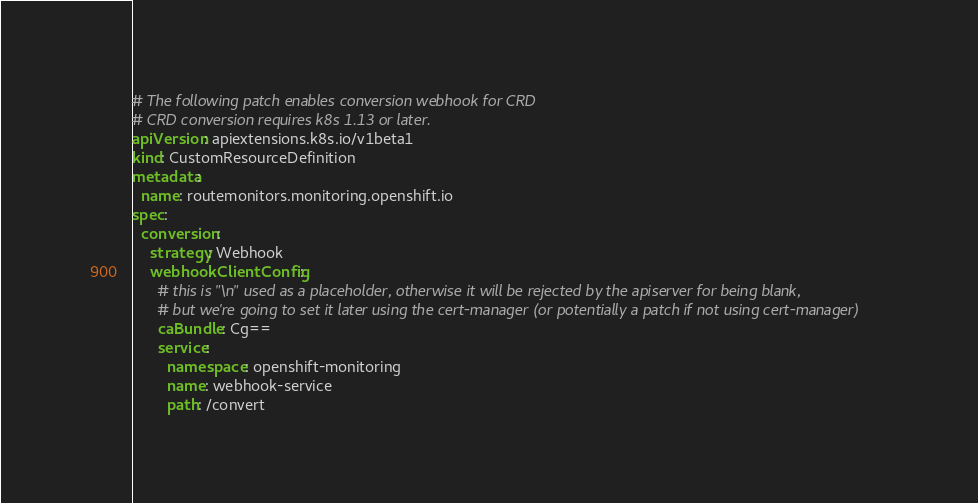<code> <loc_0><loc_0><loc_500><loc_500><_YAML_># The following patch enables conversion webhook for CRD
# CRD conversion requires k8s 1.13 or later.
apiVersion: apiextensions.k8s.io/v1beta1
kind: CustomResourceDefinition
metadata:
  name: routemonitors.monitoring.openshift.io
spec:
  conversion:
    strategy: Webhook
    webhookClientConfig:
      # this is "\n" used as a placeholder, otherwise it will be rejected by the apiserver for being blank,
      # but we're going to set it later using the cert-manager (or potentially a patch if not using cert-manager)
      caBundle: Cg==
      service:
        namespace: openshift-monitoring
        name: webhook-service
        path: /convert
</code> 